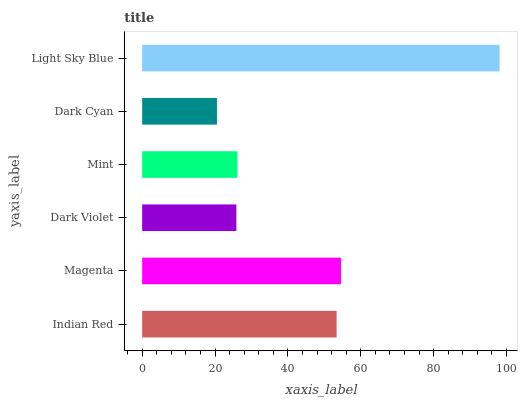Is Dark Cyan the minimum?
Answer yes or no. Yes. Is Light Sky Blue the maximum?
Answer yes or no. Yes. Is Magenta the minimum?
Answer yes or no. No. Is Magenta the maximum?
Answer yes or no. No. Is Magenta greater than Indian Red?
Answer yes or no. Yes. Is Indian Red less than Magenta?
Answer yes or no. Yes. Is Indian Red greater than Magenta?
Answer yes or no. No. Is Magenta less than Indian Red?
Answer yes or no. No. Is Indian Red the high median?
Answer yes or no. Yes. Is Mint the low median?
Answer yes or no. Yes. Is Dark Violet the high median?
Answer yes or no. No. Is Light Sky Blue the low median?
Answer yes or no. No. 